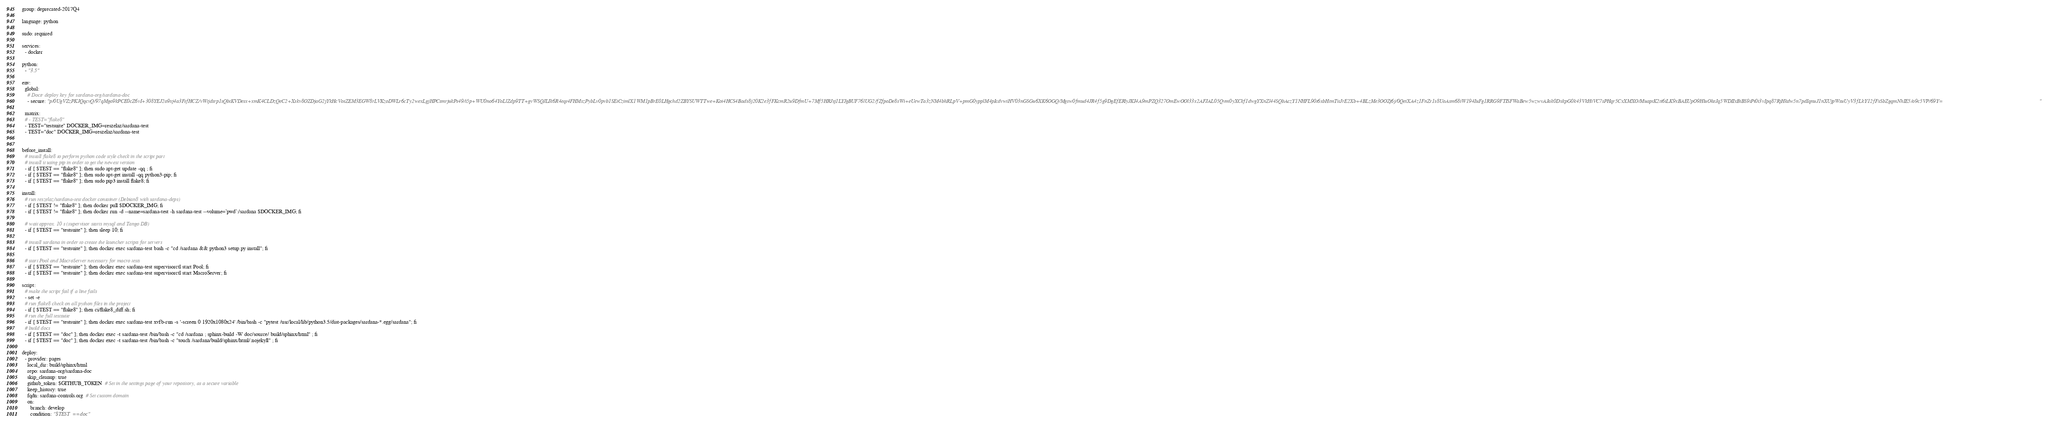<code> <loc_0><loc_0><loc_500><loc_500><_YAML_>group: deprecated-2017Q4

language: python

sudo: required

services:
  - docker

python:
  - "3.5"

env:
  global:
    # Doctr deploy key for sardana-org/sardana-doc
    - secure: "p/0UgVZzPKJQqcvQ/97qMgo9kPCE0cZ6vI+308YEJ2o9xj4a3FsfHCZ/vWtjdsrp1sQbtKVDesx+xmK4CLDzQeC2+Xskv8OZDjaG2jYkHcVosZEM3EGW8rLVKzoDWLr6cTy2wexLgjHPCsmrjukPs49/i5p+WU0no64YoLlZdp9TT+gvWSQJLIk6R4eqt4FHMszPybLv0pvb1SEiCzimlX1WM1pBrE0LHgchd2ZBYSUWTTwe+Koi4HCS4Bads8j20K2e3fFKcmR2u9DfmU+7Mf5HRJsj1LYJgBUF76lUG2/fZfpoDe8sWi+eUewTa3zNM4bhRLpV+pmG0ypplM4pIcdvwiHV03nGSGu6XK6OGQ/Mgsw0fmud4JR4f5g9DgEfERlyJKI4A9mPZQ327OmEwOOl33x2AFJAL05Qvm0yXCkf1dwgYXnZl44SQbAczY1NHFL90t6xbHtmTitJrE2Xb+4BLzMe3OOZj6j/0QeiXA4z1FnZr1s8UoAsm68iW194IuFg1RRG9FTISFWaBew5wzwvAJak0DxkpG0k43VkHiVC7sPHqr5CxXMXO/MuaptK2ti6iLK9xBAEUpO9HluOkeJq5WDIIxBiBS9tPi0i3vIpq87RjHkdw5n7pdIqnuJ1nXUjpWsuUyV3fLkY12fFxSbZgqmNhIE5/o9c5VP/69Y="

  matrix:
  # - TEST="flake8"
  - TEST="testsuite" DOCKER_IMG=reszelaz/sardana-test
  - TEST="doc" DOCKER_IMG=reszelaz/sardana-test


before_install:
  # install flake8 to perform python code style check in the script part
  # install it using pip in order to get the newest version
  - if [ $TEST == "flake8" ]; then sudo apt-get update -qq ; fi
  - if [ $TEST == "flake8" ]; then sudo apt-get install -qq python3-pip; fi
  - if [ $TEST == "flake8" ]; then sudo pip3 install flake8; fi

install:
  # run reszelaz/sardana-test docker container (Debian8 with sardana-deps)
  - if [ $TEST != "flake8" ]; then docker pull $DOCKER_IMG; fi
  - if [ $TEST != "flake8" ]; then docker run -d --name=sardana-test -h sardana-test --volume=`pwd`:/sardana $DOCKER_IMG; fi

  # wait approx. 10 s (supervisor starts mysql and Tango DB)
  - if [ $TEST == "testsuite" ]; then sleep 10; fi

  # install sardana in order to create the launcher scripts for servers
  - if [ $TEST == "testsuite" ]; then docker exec sardana-test bash -c "cd /sardana && python3 setup.py install"; fi

  # start Pool and MacroServer necessary for macro tests
  - if [ $TEST == "testsuite" ]; then docker exec sardana-test supervisorctl start Pool; fi
  - if [ $TEST == "testsuite" ]; then docker exec sardana-test supervisorctl start MacroServer; fi

script:
  # make the script fail if a line fails
  - set -e
  # run flake8 check on all python files in the project
  - if [ $TEST == "flake8" ]; then ci/flake8_diff.sh; fi
  # run the full testsuite
  - if [ $TEST == "testsuite" ]; then docker exec sardana-test xvfb-run -s '-screen 0 1920x1080x24' /bin/bash -c "pytest /usr/local/lib/python3.5/dist-packages/sardana-*.egg/sardana"; fi
  # build docs
  - if [ $TEST == "doc" ]; then docker exec -t sardana-test /bin/bash -c "cd /sardana ; sphinx-build -W doc/source/ build/sphinx/html" ; fi
  - if [ $TEST == "doc" ]; then docker exec -t sardana-test /bin/bash -c "touch /sardana/build/sphinx/html/.nojekyll" ; fi

deploy:
  - provider: pages
    local_dir: build/sphinx/html
    repo: sardana-org/sardana-doc
    skip_cleanup: true
    github_token: $GITHUB_TOKEN  # Set in the settings page of your repository, as a secure variable
    keep_history: true
    fqdn: sardana-controls.org  # Set custom domain
    on:
      branch: develop
      condition: "$TEST == doc"
</code> 